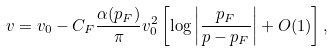Convert formula to latex. <formula><loc_0><loc_0><loc_500><loc_500>v = v _ { 0 } - C _ { F } \frac { \alpha ( p _ { F } ) } { \pi } v _ { 0 } ^ { 2 } \left [ \log \left | \frac { p _ { F } } { p - p _ { F } } \right | + O ( 1 ) \right ] ,</formula> 